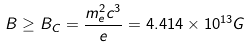Convert formula to latex. <formula><loc_0><loc_0><loc_500><loc_500>B \geq B _ { C } = \frac { m _ { e } ^ { 2 } c ^ { 3 } } { e } = 4 . 4 1 4 \times 1 0 ^ { 1 3 } G</formula> 